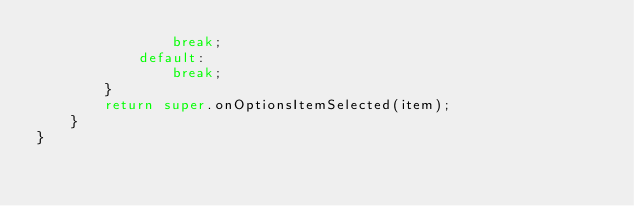<code> <loc_0><loc_0><loc_500><loc_500><_Java_>                break;
            default:
                break;
        }
        return super.onOptionsItemSelected(item);
    }
}
</code> 